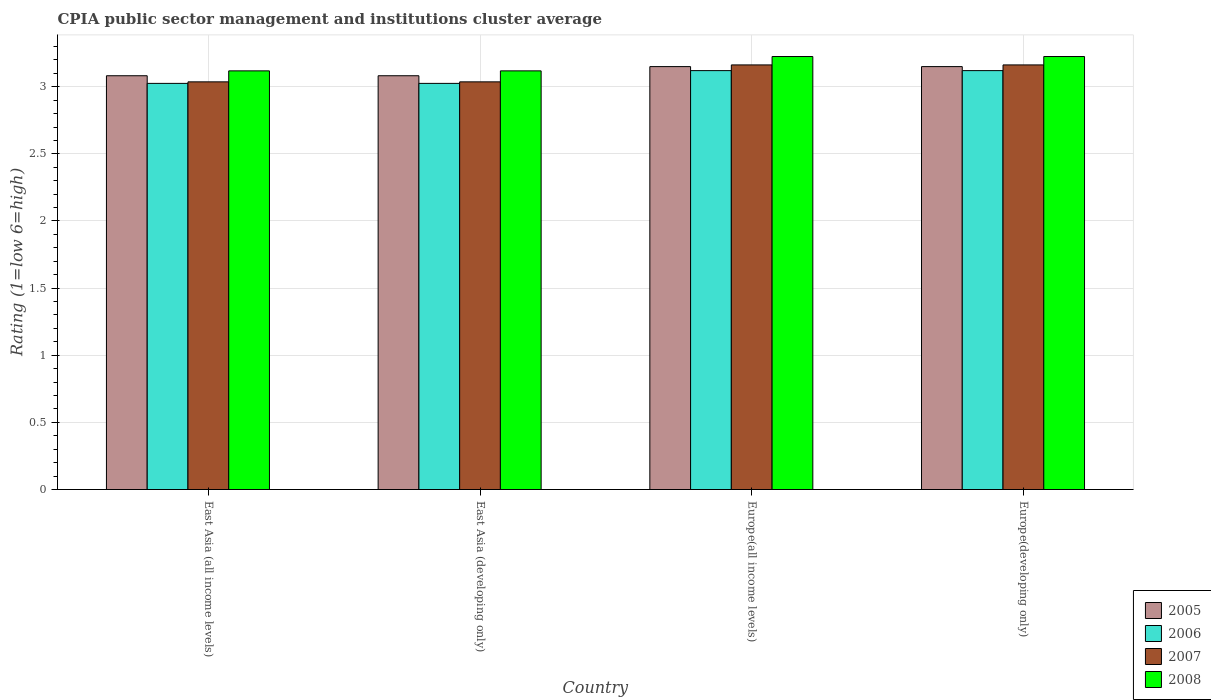How many different coloured bars are there?
Offer a terse response. 4. How many groups of bars are there?
Ensure brevity in your answer.  4. How many bars are there on the 4th tick from the right?
Your answer should be compact. 4. What is the label of the 3rd group of bars from the left?
Make the answer very short. Europe(all income levels). In how many cases, is the number of bars for a given country not equal to the number of legend labels?
Keep it short and to the point. 0. What is the CPIA rating in 2007 in East Asia (all income levels)?
Provide a short and direct response. 3.04. Across all countries, what is the maximum CPIA rating in 2008?
Keep it short and to the point. 3.23. Across all countries, what is the minimum CPIA rating in 2005?
Ensure brevity in your answer.  3.08. In which country was the CPIA rating in 2008 maximum?
Give a very brief answer. Europe(all income levels). In which country was the CPIA rating in 2005 minimum?
Your response must be concise. East Asia (all income levels). What is the total CPIA rating in 2007 in the graph?
Ensure brevity in your answer.  12.4. What is the difference between the CPIA rating in 2006 in East Asia (all income levels) and that in Europe(developing only)?
Provide a short and direct response. -0.1. What is the difference between the CPIA rating in 2005 in East Asia (developing only) and the CPIA rating in 2007 in Europe(developing only)?
Give a very brief answer. -0.08. What is the average CPIA rating in 2006 per country?
Your answer should be very brief. 3.07. What is the difference between the CPIA rating of/in 2006 and CPIA rating of/in 2007 in Europe(developing only)?
Offer a very short reply. -0.04. What is the ratio of the CPIA rating in 2005 in East Asia (developing only) to that in Europe(developing only)?
Ensure brevity in your answer.  0.98. Is the difference between the CPIA rating in 2006 in East Asia (all income levels) and East Asia (developing only) greater than the difference between the CPIA rating in 2007 in East Asia (all income levels) and East Asia (developing only)?
Give a very brief answer. No. What is the difference between the highest and the second highest CPIA rating in 2006?
Ensure brevity in your answer.  -0.1. What is the difference between the highest and the lowest CPIA rating in 2007?
Offer a terse response. 0.13. In how many countries, is the CPIA rating in 2007 greater than the average CPIA rating in 2007 taken over all countries?
Give a very brief answer. 2. Is the sum of the CPIA rating in 2005 in East Asia (developing only) and Europe(all income levels) greater than the maximum CPIA rating in 2008 across all countries?
Provide a succinct answer. Yes. Is it the case that in every country, the sum of the CPIA rating in 2007 and CPIA rating in 2008 is greater than the sum of CPIA rating in 2006 and CPIA rating in 2005?
Keep it short and to the point. Yes. What does the 1st bar from the right in East Asia (developing only) represents?
Give a very brief answer. 2008. How many bars are there?
Make the answer very short. 16. How many countries are there in the graph?
Offer a very short reply. 4. What is the difference between two consecutive major ticks on the Y-axis?
Offer a very short reply. 0.5. Are the values on the major ticks of Y-axis written in scientific E-notation?
Offer a terse response. No. How are the legend labels stacked?
Offer a terse response. Vertical. What is the title of the graph?
Make the answer very short. CPIA public sector management and institutions cluster average. What is the label or title of the Y-axis?
Provide a succinct answer. Rating (1=low 6=high). What is the Rating (1=low 6=high) in 2005 in East Asia (all income levels)?
Keep it short and to the point. 3.08. What is the Rating (1=low 6=high) of 2006 in East Asia (all income levels)?
Provide a short and direct response. 3.02. What is the Rating (1=low 6=high) in 2007 in East Asia (all income levels)?
Your answer should be compact. 3.04. What is the Rating (1=low 6=high) of 2008 in East Asia (all income levels)?
Your response must be concise. 3.12. What is the Rating (1=low 6=high) of 2005 in East Asia (developing only)?
Offer a very short reply. 3.08. What is the Rating (1=low 6=high) of 2006 in East Asia (developing only)?
Give a very brief answer. 3.02. What is the Rating (1=low 6=high) of 2007 in East Asia (developing only)?
Your answer should be compact. 3.04. What is the Rating (1=low 6=high) in 2008 in East Asia (developing only)?
Your response must be concise. 3.12. What is the Rating (1=low 6=high) of 2005 in Europe(all income levels)?
Your answer should be very brief. 3.15. What is the Rating (1=low 6=high) of 2006 in Europe(all income levels)?
Make the answer very short. 3.12. What is the Rating (1=low 6=high) of 2007 in Europe(all income levels)?
Make the answer very short. 3.16. What is the Rating (1=low 6=high) of 2008 in Europe(all income levels)?
Offer a terse response. 3.23. What is the Rating (1=low 6=high) in 2005 in Europe(developing only)?
Ensure brevity in your answer.  3.15. What is the Rating (1=low 6=high) in 2006 in Europe(developing only)?
Make the answer very short. 3.12. What is the Rating (1=low 6=high) of 2007 in Europe(developing only)?
Provide a short and direct response. 3.16. What is the Rating (1=low 6=high) in 2008 in Europe(developing only)?
Offer a very short reply. 3.23. Across all countries, what is the maximum Rating (1=low 6=high) in 2005?
Ensure brevity in your answer.  3.15. Across all countries, what is the maximum Rating (1=low 6=high) in 2006?
Your answer should be very brief. 3.12. Across all countries, what is the maximum Rating (1=low 6=high) in 2007?
Your answer should be compact. 3.16. Across all countries, what is the maximum Rating (1=low 6=high) in 2008?
Your answer should be very brief. 3.23. Across all countries, what is the minimum Rating (1=low 6=high) in 2005?
Provide a short and direct response. 3.08. Across all countries, what is the minimum Rating (1=low 6=high) of 2006?
Make the answer very short. 3.02. Across all countries, what is the minimum Rating (1=low 6=high) in 2007?
Your answer should be compact. 3.04. Across all countries, what is the minimum Rating (1=low 6=high) of 2008?
Ensure brevity in your answer.  3.12. What is the total Rating (1=low 6=high) of 2005 in the graph?
Ensure brevity in your answer.  12.46. What is the total Rating (1=low 6=high) of 2006 in the graph?
Offer a terse response. 12.29. What is the total Rating (1=low 6=high) of 2007 in the graph?
Make the answer very short. 12.4. What is the total Rating (1=low 6=high) in 2008 in the graph?
Provide a short and direct response. 12.69. What is the difference between the Rating (1=low 6=high) of 2005 in East Asia (all income levels) and that in East Asia (developing only)?
Provide a succinct answer. 0. What is the difference between the Rating (1=low 6=high) in 2007 in East Asia (all income levels) and that in East Asia (developing only)?
Keep it short and to the point. 0. What is the difference between the Rating (1=low 6=high) in 2008 in East Asia (all income levels) and that in East Asia (developing only)?
Give a very brief answer. 0. What is the difference between the Rating (1=low 6=high) in 2005 in East Asia (all income levels) and that in Europe(all income levels)?
Keep it short and to the point. -0.07. What is the difference between the Rating (1=low 6=high) in 2006 in East Asia (all income levels) and that in Europe(all income levels)?
Keep it short and to the point. -0.1. What is the difference between the Rating (1=low 6=high) of 2007 in East Asia (all income levels) and that in Europe(all income levels)?
Keep it short and to the point. -0.13. What is the difference between the Rating (1=low 6=high) in 2008 in East Asia (all income levels) and that in Europe(all income levels)?
Your response must be concise. -0.11. What is the difference between the Rating (1=low 6=high) of 2005 in East Asia (all income levels) and that in Europe(developing only)?
Make the answer very short. -0.07. What is the difference between the Rating (1=low 6=high) in 2006 in East Asia (all income levels) and that in Europe(developing only)?
Your answer should be compact. -0.1. What is the difference between the Rating (1=low 6=high) in 2007 in East Asia (all income levels) and that in Europe(developing only)?
Keep it short and to the point. -0.13. What is the difference between the Rating (1=low 6=high) of 2008 in East Asia (all income levels) and that in Europe(developing only)?
Make the answer very short. -0.11. What is the difference between the Rating (1=low 6=high) of 2005 in East Asia (developing only) and that in Europe(all income levels)?
Provide a short and direct response. -0.07. What is the difference between the Rating (1=low 6=high) of 2006 in East Asia (developing only) and that in Europe(all income levels)?
Ensure brevity in your answer.  -0.1. What is the difference between the Rating (1=low 6=high) in 2007 in East Asia (developing only) and that in Europe(all income levels)?
Give a very brief answer. -0.13. What is the difference between the Rating (1=low 6=high) in 2008 in East Asia (developing only) and that in Europe(all income levels)?
Keep it short and to the point. -0.11. What is the difference between the Rating (1=low 6=high) in 2005 in East Asia (developing only) and that in Europe(developing only)?
Provide a succinct answer. -0.07. What is the difference between the Rating (1=low 6=high) of 2006 in East Asia (developing only) and that in Europe(developing only)?
Offer a very short reply. -0.1. What is the difference between the Rating (1=low 6=high) of 2007 in East Asia (developing only) and that in Europe(developing only)?
Your answer should be compact. -0.13. What is the difference between the Rating (1=low 6=high) in 2008 in East Asia (developing only) and that in Europe(developing only)?
Ensure brevity in your answer.  -0.11. What is the difference between the Rating (1=low 6=high) of 2005 in East Asia (all income levels) and the Rating (1=low 6=high) of 2006 in East Asia (developing only)?
Offer a terse response. 0.06. What is the difference between the Rating (1=low 6=high) of 2005 in East Asia (all income levels) and the Rating (1=low 6=high) of 2007 in East Asia (developing only)?
Ensure brevity in your answer.  0.05. What is the difference between the Rating (1=low 6=high) of 2005 in East Asia (all income levels) and the Rating (1=low 6=high) of 2008 in East Asia (developing only)?
Give a very brief answer. -0.04. What is the difference between the Rating (1=low 6=high) of 2006 in East Asia (all income levels) and the Rating (1=low 6=high) of 2007 in East Asia (developing only)?
Provide a short and direct response. -0.01. What is the difference between the Rating (1=low 6=high) in 2006 in East Asia (all income levels) and the Rating (1=low 6=high) in 2008 in East Asia (developing only)?
Make the answer very short. -0.09. What is the difference between the Rating (1=low 6=high) in 2007 in East Asia (all income levels) and the Rating (1=low 6=high) in 2008 in East Asia (developing only)?
Ensure brevity in your answer.  -0.08. What is the difference between the Rating (1=low 6=high) in 2005 in East Asia (all income levels) and the Rating (1=low 6=high) in 2006 in Europe(all income levels)?
Provide a short and direct response. -0.04. What is the difference between the Rating (1=low 6=high) in 2005 in East Asia (all income levels) and the Rating (1=low 6=high) in 2007 in Europe(all income levels)?
Provide a short and direct response. -0.08. What is the difference between the Rating (1=low 6=high) of 2005 in East Asia (all income levels) and the Rating (1=low 6=high) of 2008 in Europe(all income levels)?
Offer a very short reply. -0.14. What is the difference between the Rating (1=low 6=high) of 2006 in East Asia (all income levels) and the Rating (1=low 6=high) of 2007 in Europe(all income levels)?
Your response must be concise. -0.14. What is the difference between the Rating (1=low 6=high) of 2007 in East Asia (all income levels) and the Rating (1=low 6=high) of 2008 in Europe(all income levels)?
Your answer should be compact. -0.19. What is the difference between the Rating (1=low 6=high) in 2005 in East Asia (all income levels) and the Rating (1=low 6=high) in 2006 in Europe(developing only)?
Provide a succinct answer. -0.04. What is the difference between the Rating (1=low 6=high) in 2005 in East Asia (all income levels) and the Rating (1=low 6=high) in 2007 in Europe(developing only)?
Provide a short and direct response. -0.08. What is the difference between the Rating (1=low 6=high) of 2005 in East Asia (all income levels) and the Rating (1=low 6=high) of 2008 in Europe(developing only)?
Provide a succinct answer. -0.14. What is the difference between the Rating (1=low 6=high) in 2006 in East Asia (all income levels) and the Rating (1=low 6=high) in 2007 in Europe(developing only)?
Ensure brevity in your answer.  -0.14. What is the difference between the Rating (1=low 6=high) in 2006 in East Asia (all income levels) and the Rating (1=low 6=high) in 2008 in Europe(developing only)?
Offer a very short reply. -0.2. What is the difference between the Rating (1=low 6=high) of 2007 in East Asia (all income levels) and the Rating (1=low 6=high) of 2008 in Europe(developing only)?
Offer a terse response. -0.19. What is the difference between the Rating (1=low 6=high) of 2005 in East Asia (developing only) and the Rating (1=low 6=high) of 2006 in Europe(all income levels)?
Keep it short and to the point. -0.04. What is the difference between the Rating (1=low 6=high) of 2005 in East Asia (developing only) and the Rating (1=low 6=high) of 2007 in Europe(all income levels)?
Offer a very short reply. -0.08. What is the difference between the Rating (1=low 6=high) in 2005 in East Asia (developing only) and the Rating (1=low 6=high) in 2008 in Europe(all income levels)?
Your answer should be compact. -0.14. What is the difference between the Rating (1=low 6=high) of 2006 in East Asia (developing only) and the Rating (1=low 6=high) of 2007 in Europe(all income levels)?
Offer a terse response. -0.14. What is the difference between the Rating (1=low 6=high) of 2006 in East Asia (developing only) and the Rating (1=low 6=high) of 2008 in Europe(all income levels)?
Your response must be concise. -0.2. What is the difference between the Rating (1=low 6=high) of 2007 in East Asia (developing only) and the Rating (1=low 6=high) of 2008 in Europe(all income levels)?
Give a very brief answer. -0.19. What is the difference between the Rating (1=low 6=high) of 2005 in East Asia (developing only) and the Rating (1=low 6=high) of 2006 in Europe(developing only)?
Your response must be concise. -0.04. What is the difference between the Rating (1=low 6=high) of 2005 in East Asia (developing only) and the Rating (1=low 6=high) of 2007 in Europe(developing only)?
Offer a terse response. -0.08. What is the difference between the Rating (1=low 6=high) of 2005 in East Asia (developing only) and the Rating (1=low 6=high) of 2008 in Europe(developing only)?
Provide a short and direct response. -0.14. What is the difference between the Rating (1=low 6=high) in 2006 in East Asia (developing only) and the Rating (1=low 6=high) in 2007 in Europe(developing only)?
Your answer should be compact. -0.14. What is the difference between the Rating (1=low 6=high) in 2006 in East Asia (developing only) and the Rating (1=low 6=high) in 2008 in Europe(developing only)?
Provide a short and direct response. -0.2. What is the difference between the Rating (1=low 6=high) in 2007 in East Asia (developing only) and the Rating (1=low 6=high) in 2008 in Europe(developing only)?
Your response must be concise. -0.19. What is the difference between the Rating (1=low 6=high) in 2005 in Europe(all income levels) and the Rating (1=low 6=high) in 2007 in Europe(developing only)?
Provide a short and direct response. -0.01. What is the difference between the Rating (1=low 6=high) in 2005 in Europe(all income levels) and the Rating (1=low 6=high) in 2008 in Europe(developing only)?
Keep it short and to the point. -0.07. What is the difference between the Rating (1=low 6=high) of 2006 in Europe(all income levels) and the Rating (1=low 6=high) of 2007 in Europe(developing only)?
Provide a short and direct response. -0.04. What is the difference between the Rating (1=low 6=high) in 2006 in Europe(all income levels) and the Rating (1=low 6=high) in 2008 in Europe(developing only)?
Keep it short and to the point. -0.1. What is the difference between the Rating (1=low 6=high) in 2007 in Europe(all income levels) and the Rating (1=low 6=high) in 2008 in Europe(developing only)?
Provide a succinct answer. -0.06. What is the average Rating (1=low 6=high) in 2005 per country?
Give a very brief answer. 3.12. What is the average Rating (1=low 6=high) of 2006 per country?
Your answer should be very brief. 3.07. What is the average Rating (1=low 6=high) of 2007 per country?
Provide a short and direct response. 3.1. What is the average Rating (1=low 6=high) in 2008 per country?
Ensure brevity in your answer.  3.17. What is the difference between the Rating (1=low 6=high) of 2005 and Rating (1=low 6=high) of 2006 in East Asia (all income levels)?
Offer a very short reply. 0.06. What is the difference between the Rating (1=low 6=high) in 2005 and Rating (1=low 6=high) in 2007 in East Asia (all income levels)?
Provide a succinct answer. 0.05. What is the difference between the Rating (1=low 6=high) of 2005 and Rating (1=low 6=high) of 2008 in East Asia (all income levels)?
Make the answer very short. -0.04. What is the difference between the Rating (1=low 6=high) in 2006 and Rating (1=low 6=high) in 2007 in East Asia (all income levels)?
Make the answer very short. -0.01. What is the difference between the Rating (1=low 6=high) in 2006 and Rating (1=low 6=high) in 2008 in East Asia (all income levels)?
Ensure brevity in your answer.  -0.09. What is the difference between the Rating (1=low 6=high) of 2007 and Rating (1=low 6=high) of 2008 in East Asia (all income levels)?
Provide a succinct answer. -0.08. What is the difference between the Rating (1=low 6=high) in 2005 and Rating (1=low 6=high) in 2006 in East Asia (developing only)?
Keep it short and to the point. 0.06. What is the difference between the Rating (1=low 6=high) in 2005 and Rating (1=low 6=high) in 2007 in East Asia (developing only)?
Make the answer very short. 0.05. What is the difference between the Rating (1=low 6=high) of 2005 and Rating (1=low 6=high) of 2008 in East Asia (developing only)?
Offer a very short reply. -0.04. What is the difference between the Rating (1=low 6=high) in 2006 and Rating (1=low 6=high) in 2007 in East Asia (developing only)?
Keep it short and to the point. -0.01. What is the difference between the Rating (1=low 6=high) of 2006 and Rating (1=low 6=high) of 2008 in East Asia (developing only)?
Your response must be concise. -0.09. What is the difference between the Rating (1=low 6=high) of 2007 and Rating (1=low 6=high) of 2008 in East Asia (developing only)?
Ensure brevity in your answer.  -0.08. What is the difference between the Rating (1=low 6=high) of 2005 and Rating (1=low 6=high) of 2006 in Europe(all income levels)?
Offer a terse response. 0.03. What is the difference between the Rating (1=low 6=high) of 2005 and Rating (1=low 6=high) of 2007 in Europe(all income levels)?
Make the answer very short. -0.01. What is the difference between the Rating (1=low 6=high) in 2005 and Rating (1=low 6=high) in 2008 in Europe(all income levels)?
Ensure brevity in your answer.  -0.07. What is the difference between the Rating (1=low 6=high) of 2006 and Rating (1=low 6=high) of 2007 in Europe(all income levels)?
Your answer should be compact. -0.04. What is the difference between the Rating (1=low 6=high) in 2006 and Rating (1=low 6=high) in 2008 in Europe(all income levels)?
Offer a terse response. -0.1. What is the difference between the Rating (1=low 6=high) in 2007 and Rating (1=low 6=high) in 2008 in Europe(all income levels)?
Make the answer very short. -0.06. What is the difference between the Rating (1=low 6=high) in 2005 and Rating (1=low 6=high) in 2006 in Europe(developing only)?
Give a very brief answer. 0.03. What is the difference between the Rating (1=low 6=high) in 2005 and Rating (1=low 6=high) in 2007 in Europe(developing only)?
Your answer should be very brief. -0.01. What is the difference between the Rating (1=low 6=high) in 2005 and Rating (1=low 6=high) in 2008 in Europe(developing only)?
Offer a terse response. -0.07. What is the difference between the Rating (1=low 6=high) in 2006 and Rating (1=low 6=high) in 2007 in Europe(developing only)?
Give a very brief answer. -0.04. What is the difference between the Rating (1=low 6=high) of 2006 and Rating (1=low 6=high) of 2008 in Europe(developing only)?
Offer a terse response. -0.1. What is the difference between the Rating (1=low 6=high) in 2007 and Rating (1=low 6=high) in 2008 in Europe(developing only)?
Offer a very short reply. -0.06. What is the ratio of the Rating (1=low 6=high) of 2005 in East Asia (all income levels) to that in East Asia (developing only)?
Your answer should be very brief. 1. What is the ratio of the Rating (1=low 6=high) of 2006 in East Asia (all income levels) to that in East Asia (developing only)?
Give a very brief answer. 1. What is the ratio of the Rating (1=low 6=high) of 2005 in East Asia (all income levels) to that in Europe(all income levels)?
Ensure brevity in your answer.  0.98. What is the ratio of the Rating (1=low 6=high) of 2006 in East Asia (all income levels) to that in Europe(all income levels)?
Your response must be concise. 0.97. What is the ratio of the Rating (1=low 6=high) in 2007 in East Asia (all income levels) to that in Europe(all income levels)?
Ensure brevity in your answer.  0.96. What is the ratio of the Rating (1=low 6=high) in 2008 in East Asia (all income levels) to that in Europe(all income levels)?
Ensure brevity in your answer.  0.97. What is the ratio of the Rating (1=low 6=high) in 2005 in East Asia (all income levels) to that in Europe(developing only)?
Ensure brevity in your answer.  0.98. What is the ratio of the Rating (1=low 6=high) of 2006 in East Asia (all income levels) to that in Europe(developing only)?
Give a very brief answer. 0.97. What is the ratio of the Rating (1=low 6=high) of 2007 in East Asia (all income levels) to that in Europe(developing only)?
Give a very brief answer. 0.96. What is the ratio of the Rating (1=low 6=high) in 2008 in East Asia (all income levels) to that in Europe(developing only)?
Give a very brief answer. 0.97. What is the ratio of the Rating (1=low 6=high) in 2005 in East Asia (developing only) to that in Europe(all income levels)?
Give a very brief answer. 0.98. What is the ratio of the Rating (1=low 6=high) of 2006 in East Asia (developing only) to that in Europe(all income levels)?
Your answer should be compact. 0.97. What is the ratio of the Rating (1=low 6=high) of 2007 in East Asia (developing only) to that in Europe(all income levels)?
Give a very brief answer. 0.96. What is the ratio of the Rating (1=low 6=high) in 2008 in East Asia (developing only) to that in Europe(all income levels)?
Provide a short and direct response. 0.97. What is the ratio of the Rating (1=low 6=high) of 2005 in East Asia (developing only) to that in Europe(developing only)?
Your response must be concise. 0.98. What is the ratio of the Rating (1=low 6=high) in 2006 in East Asia (developing only) to that in Europe(developing only)?
Make the answer very short. 0.97. What is the ratio of the Rating (1=low 6=high) in 2007 in East Asia (developing only) to that in Europe(developing only)?
Offer a very short reply. 0.96. What is the ratio of the Rating (1=low 6=high) of 2008 in East Asia (developing only) to that in Europe(developing only)?
Provide a succinct answer. 0.97. What is the ratio of the Rating (1=low 6=high) in 2008 in Europe(all income levels) to that in Europe(developing only)?
Offer a terse response. 1. What is the difference between the highest and the second highest Rating (1=low 6=high) of 2005?
Give a very brief answer. 0. What is the difference between the highest and the lowest Rating (1=low 6=high) of 2005?
Give a very brief answer. 0.07. What is the difference between the highest and the lowest Rating (1=low 6=high) in 2006?
Provide a succinct answer. 0.1. What is the difference between the highest and the lowest Rating (1=low 6=high) in 2007?
Your answer should be compact. 0.13. What is the difference between the highest and the lowest Rating (1=low 6=high) in 2008?
Your response must be concise. 0.11. 